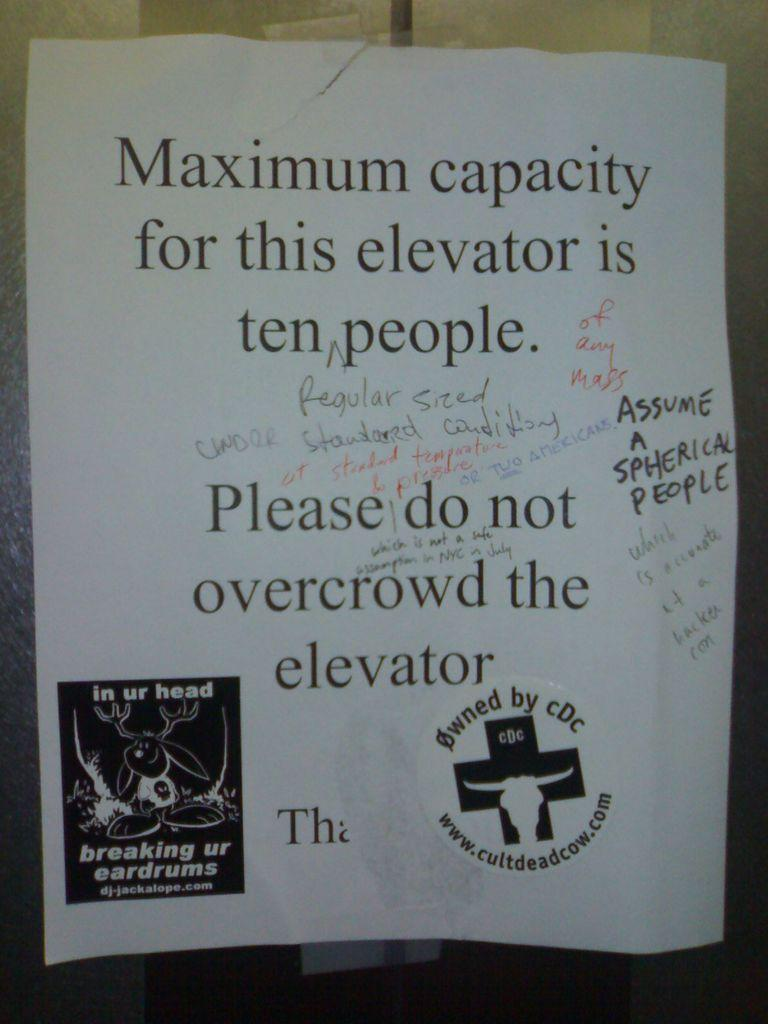<image>
Share a concise interpretation of the image provided. A poster with a sticker on it saying owned by cdc 